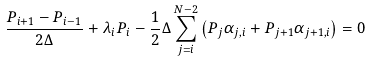Convert formula to latex. <formula><loc_0><loc_0><loc_500><loc_500>\frac { P _ { i + 1 } - P _ { i - 1 } } { 2 \Delta } + \lambda _ { i } P _ { i } - \frac { 1 } { 2 } \Delta \sum _ { j = i } ^ { N - 2 } \left ( P _ { j } \alpha _ { j , i } + P _ { j + 1 } \alpha _ { j + 1 , i } \right ) = 0</formula> 